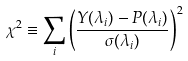Convert formula to latex. <formula><loc_0><loc_0><loc_500><loc_500>\chi ^ { 2 } \equiv \sum _ { i } \left ( \frac { Y ( \lambda _ { i } ) - P ( \lambda _ { i } ) } { \sigma ( \lambda _ { i } ) } \right ) ^ { 2 }</formula> 